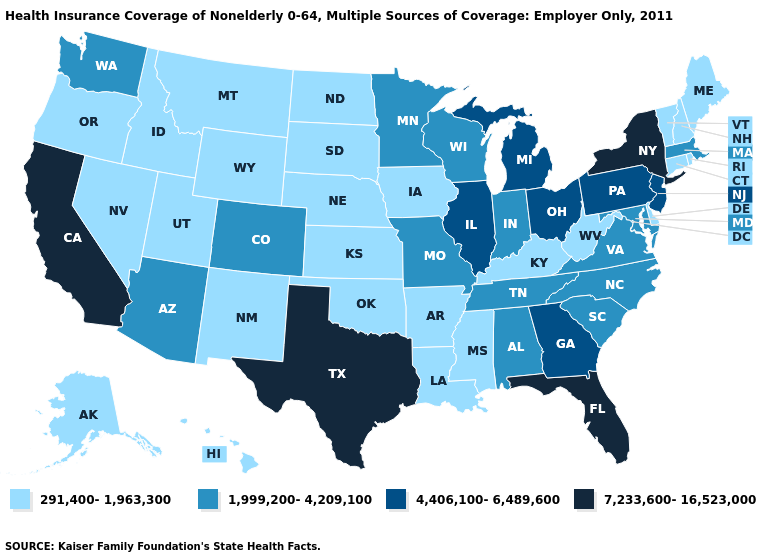Name the states that have a value in the range 4,406,100-6,489,600?
Answer briefly. Georgia, Illinois, Michigan, New Jersey, Ohio, Pennsylvania. What is the lowest value in states that border North Carolina?
Write a very short answer. 1,999,200-4,209,100. What is the highest value in the MidWest ?
Write a very short answer. 4,406,100-6,489,600. What is the highest value in the USA?
Short answer required. 7,233,600-16,523,000. Does Wisconsin have a higher value than Louisiana?
Be succinct. Yes. Which states hav the highest value in the Northeast?
Write a very short answer. New York. Which states hav the highest value in the MidWest?
Quick response, please. Illinois, Michigan, Ohio. Does Michigan have the highest value in the MidWest?
Be succinct. Yes. Name the states that have a value in the range 4,406,100-6,489,600?
Short answer required. Georgia, Illinois, Michigan, New Jersey, Ohio, Pennsylvania. Name the states that have a value in the range 4,406,100-6,489,600?
Be succinct. Georgia, Illinois, Michigan, New Jersey, Ohio, Pennsylvania. Name the states that have a value in the range 291,400-1,963,300?
Answer briefly. Alaska, Arkansas, Connecticut, Delaware, Hawaii, Idaho, Iowa, Kansas, Kentucky, Louisiana, Maine, Mississippi, Montana, Nebraska, Nevada, New Hampshire, New Mexico, North Dakota, Oklahoma, Oregon, Rhode Island, South Dakota, Utah, Vermont, West Virginia, Wyoming. What is the highest value in the Northeast ?
Write a very short answer. 7,233,600-16,523,000. What is the value of Wisconsin?
Quick response, please. 1,999,200-4,209,100. Name the states that have a value in the range 1,999,200-4,209,100?
Be succinct. Alabama, Arizona, Colorado, Indiana, Maryland, Massachusetts, Minnesota, Missouri, North Carolina, South Carolina, Tennessee, Virginia, Washington, Wisconsin. Which states have the lowest value in the USA?
Short answer required. Alaska, Arkansas, Connecticut, Delaware, Hawaii, Idaho, Iowa, Kansas, Kentucky, Louisiana, Maine, Mississippi, Montana, Nebraska, Nevada, New Hampshire, New Mexico, North Dakota, Oklahoma, Oregon, Rhode Island, South Dakota, Utah, Vermont, West Virginia, Wyoming. 